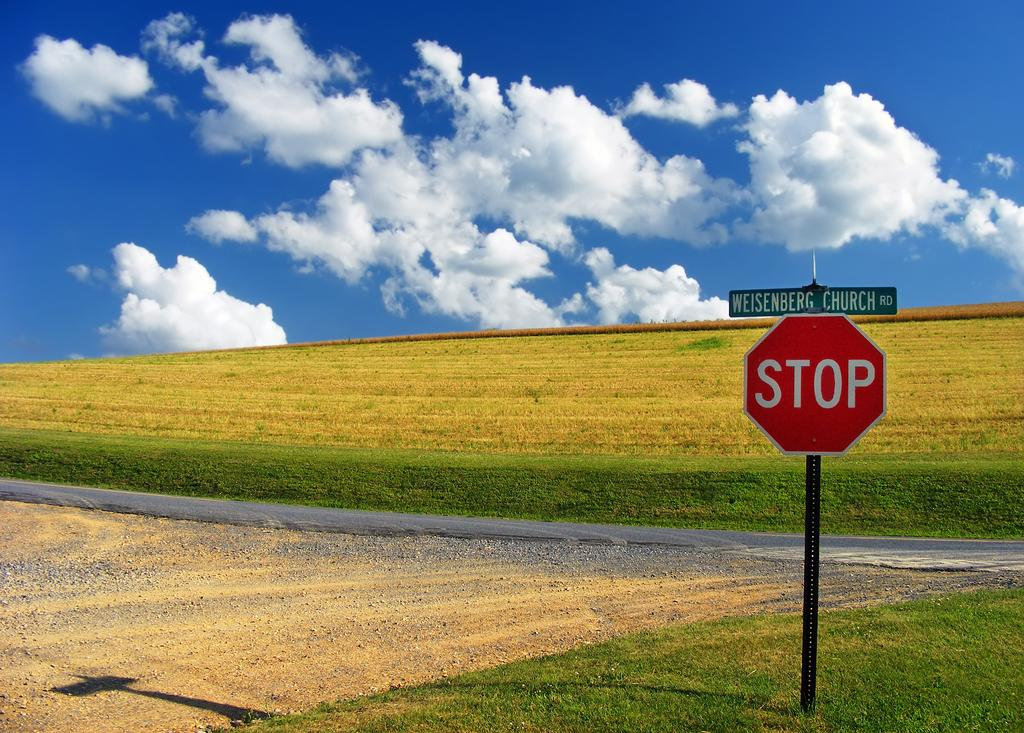<image>
Describe the image concisely. The stop sign is out in the middle of nowhere. 